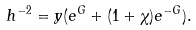Convert formula to latex. <formula><loc_0><loc_0><loc_500><loc_500>h ^ { - 2 } = y ( e ^ { G } + ( 1 + \chi ) e ^ { - G } ) .</formula> 